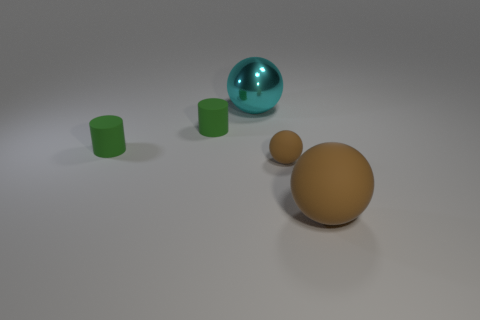Add 4 big brown rubber balls. How many objects exist? 9 Subtract all spheres. How many objects are left? 2 Add 2 tiny objects. How many tiny objects exist? 5 Subtract 1 cyan balls. How many objects are left? 4 Subtract all big things. Subtract all cyan objects. How many objects are left? 2 Add 2 brown rubber things. How many brown rubber things are left? 4 